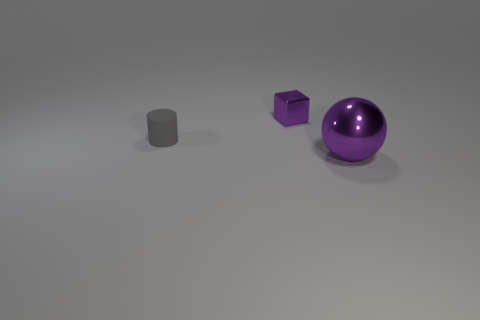Add 1 large red cubes. How many objects exist? 4 Subtract all cylinders. How many objects are left? 2 Subtract all large purple shiny things. Subtract all tiny gray matte objects. How many objects are left? 1 Add 1 large metal objects. How many large metal objects are left? 2 Add 3 tiny gray cylinders. How many tiny gray cylinders exist? 4 Subtract 0 brown cylinders. How many objects are left? 3 